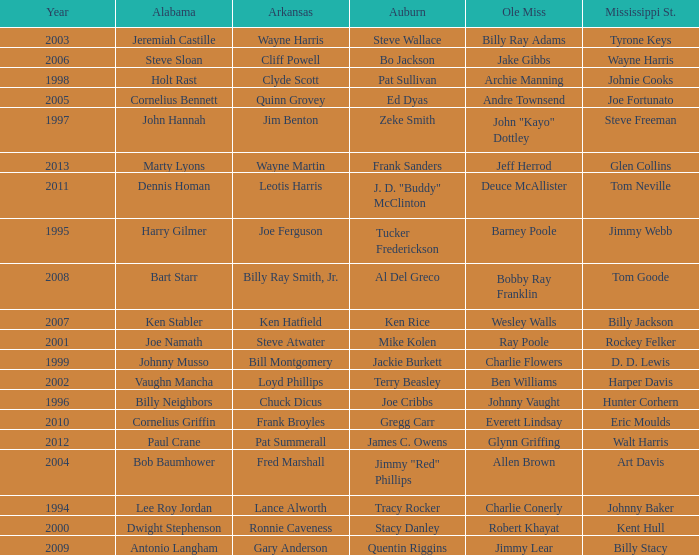Who was the player associated with Ole Miss in years after 2008 with a Mississippi St. name of Eric Moulds? Everett Lindsay. 